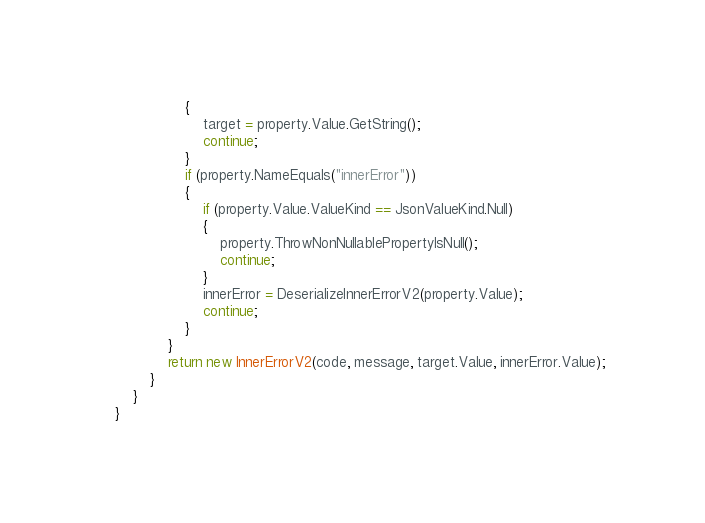<code> <loc_0><loc_0><loc_500><loc_500><_C#_>                {
                    target = property.Value.GetString();
                    continue;
                }
                if (property.NameEquals("innerError"))
                {
                    if (property.Value.ValueKind == JsonValueKind.Null)
                    {
                        property.ThrowNonNullablePropertyIsNull();
                        continue;
                    }
                    innerError = DeserializeInnerErrorV2(property.Value);
                    continue;
                }
            }
            return new InnerErrorV2(code, message, target.Value, innerError.Value);
        }
    }
}
</code> 